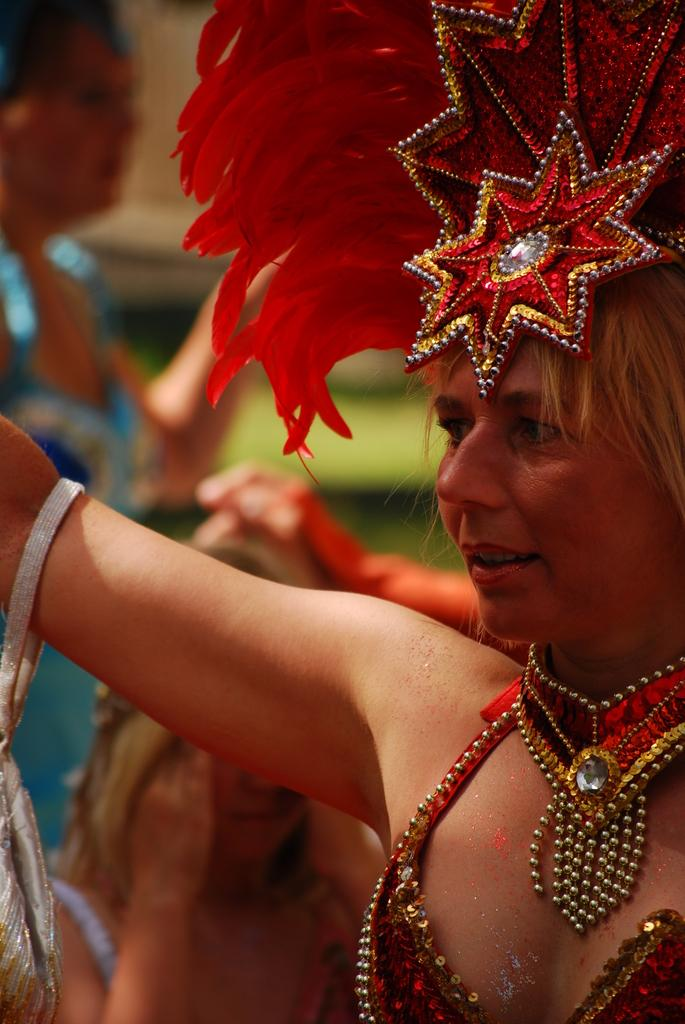Who is the main subject in the image? There is a woman in the image. What is the woman wearing on her head? The woman is wearing a crown. What other accessories can be seen on the woman? The woman is wearing jewelry. What type of accessory is present in the image that is not worn by the woman? There is a hand pouch in the image. How would you describe the background of the image? The background of the image is blurred. What type of chin can be seen on the tramp in the image? There is no tramp or chin present in the image; it features a woman wearing a crown and jewelry. What is the tramp using the pail for in the image? There is no tramp or pail present in the image. 